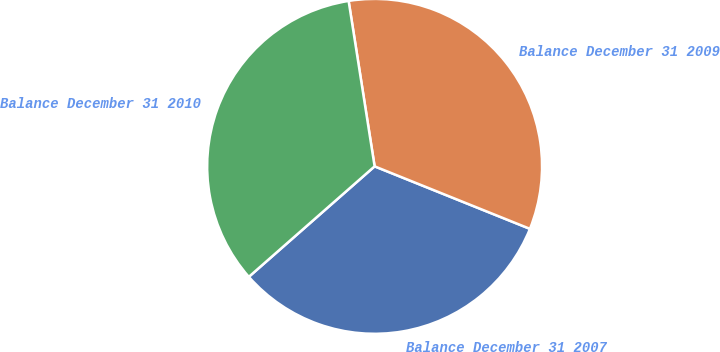Convert chart to OTSL. <chart><loc_0><loc_0><loc_500><loc_500><pie_chart><fcel>Balance December 31 2007<fcel>Balance December 31 2009<fcel>Balance December 31 2010<nl><fcel>32.44%<fcel>33.57%<fcel>33.99%<nl></chart> 